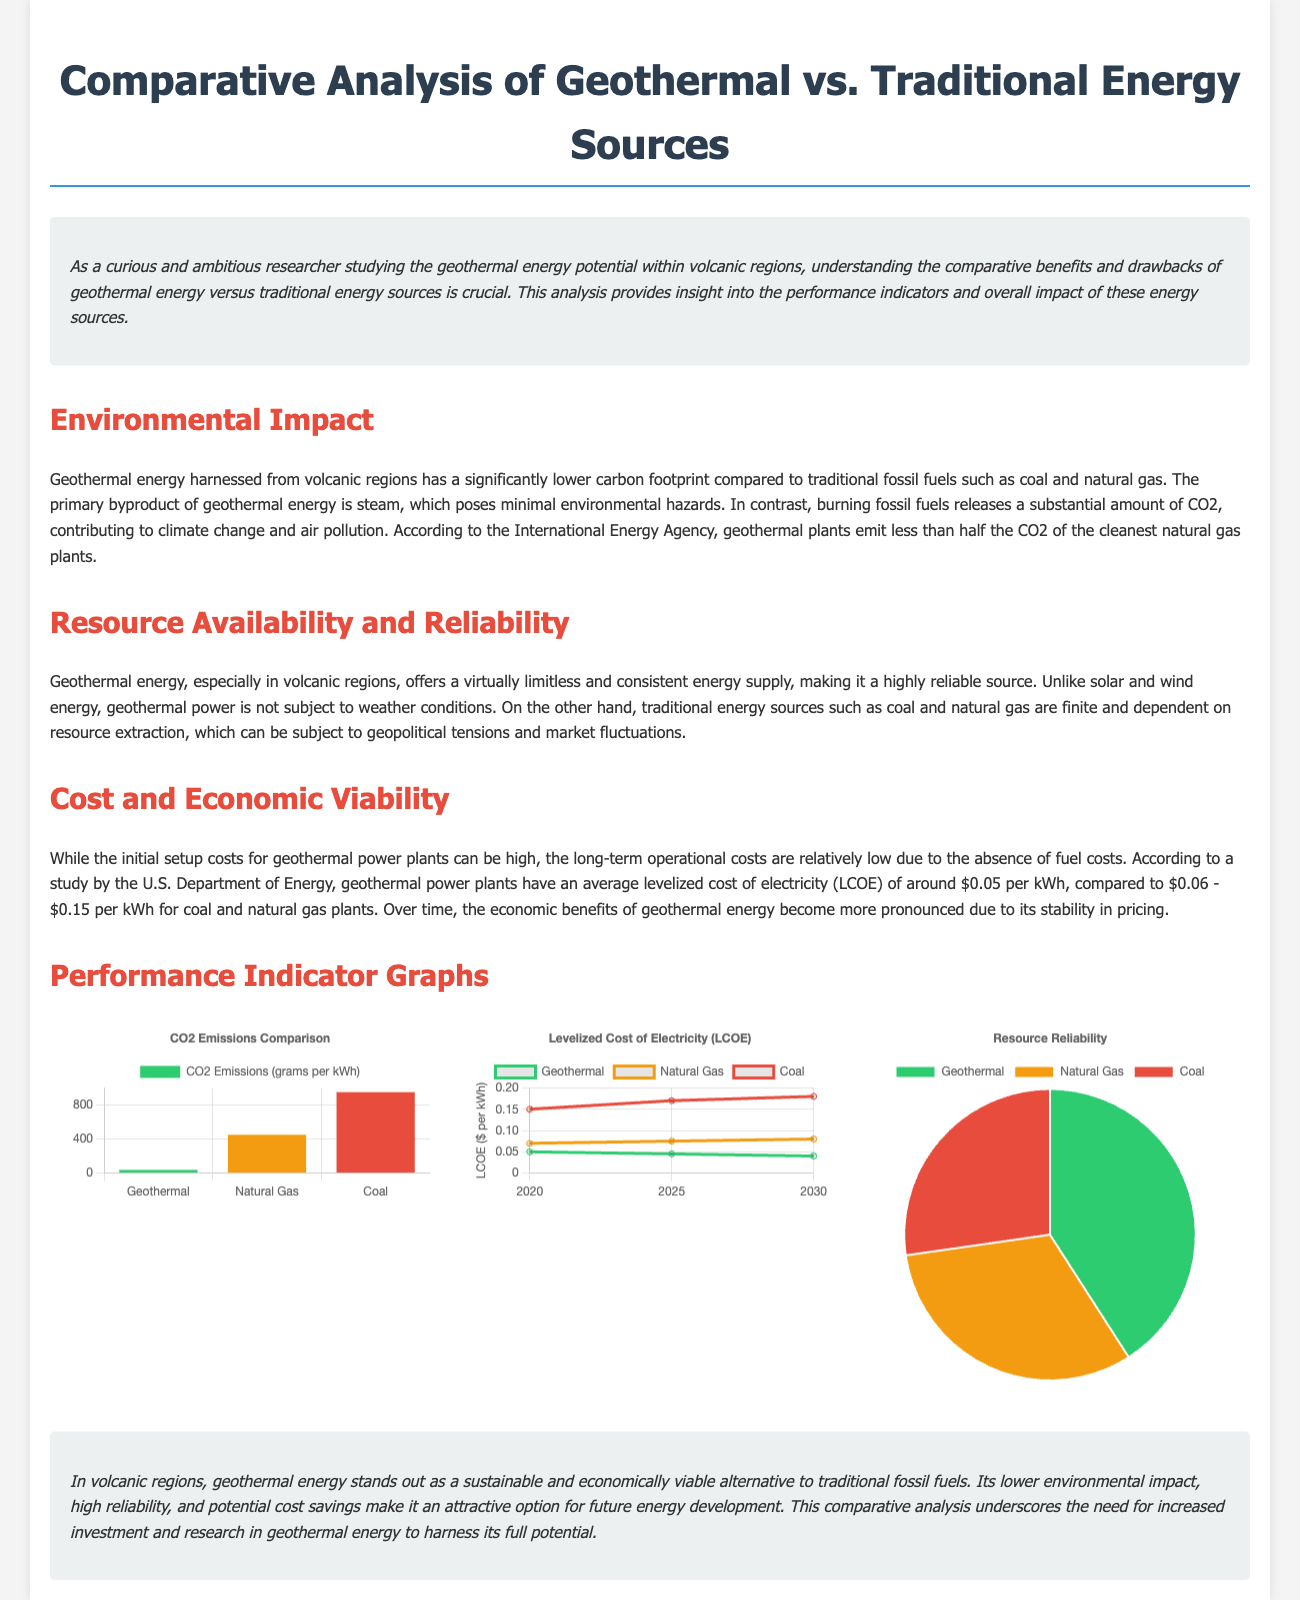What is the emissions level for Geothermal energy? The emissions level for Geothermal energy is specified in the CO2 Emissions Comparison chart as 38 grams per kWh.
Answer: 38 grams per kWh What is the average Levelized Cost of Electricity for Coal in 2030? The average Levelized Cost of Electricity for Coal in 2030 is stated in the LCOE graph as $0.18 per kWh.
Answer: $0.18 per kWh What is the reliability percentage of Geothermal energy? The reliability percentage of Geothermal energy is indicated in the Resource Reliability chart as 90%.
Answer: 90% Which energy source has the highest CO2 emissions? The energy source with the highest CO2 emissions is specified in the CO2 Emissions Comparison chart as Coal.
Answer: Coal What is the predicted Levelized Cost of Electricity for Geothermal energy in 2025? The predicted Levelized Cost of Electricity for Geothermal energy in 2025 is shown in the LCOE graph as $0.045 per kWh.
Answer: $0.045 per kWh Which traditional energy source has an LCOE range of $0.06 to $0.15 per kWh? The traditional energy source with an LCOE range of $0.06 to $0.15 per kWh is Natural Gas.
Answer: Natural Gas What is the CO2 emissions for Natural Gas? The CO2 emissions for Natural Gas is represented in the CO2 Emissions Comparison chart as 450 grams per kWh.
Answer: 450 grams per kWh What is the trend for Geothermal energy LCOE from 2020 to 2030? The trend for Geothermal energy LCOE from 2020 to 2030 is a decrease from $0.05 to $0.04 per kWh, as shown in the graph.
Answer: Decrease What is the title of the document? The title of the document is indicated at the top of the page as "Comparative Analysis of Geothermal vs. Traditional Energy Sources."
Answer: Comparative Analysis of Geothermal vs. Traditional Energy Sources 